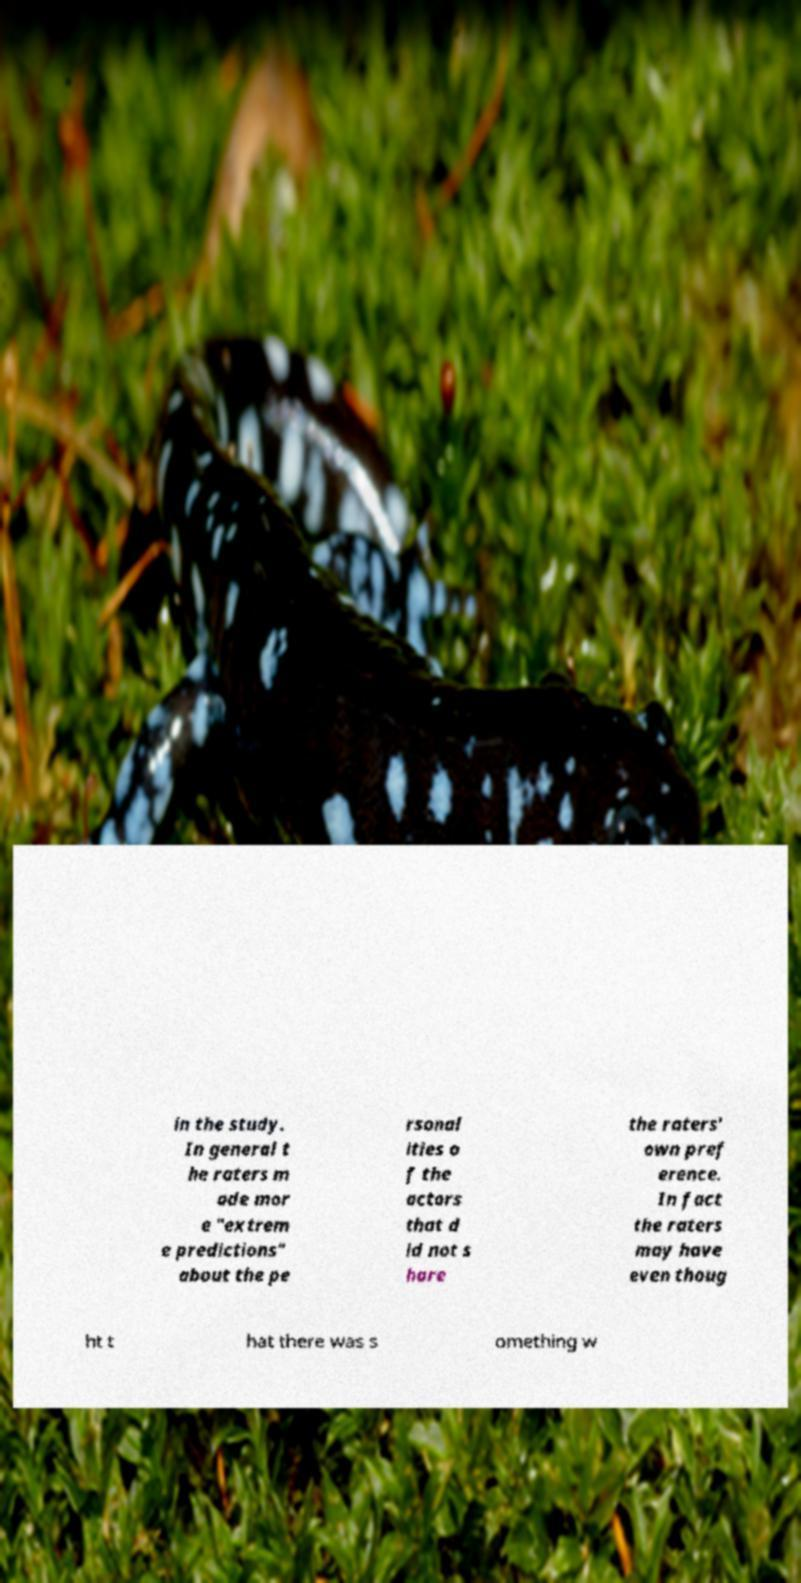Could you extract and type out the text from this image? in the study. In general t he raters m ade mor e "extrem e predictions" about the pe rsonal ities o f the actors that d id not s hare the raters' own pref erence. In fact the raters may have even thoug ht t hat there was s omething w 